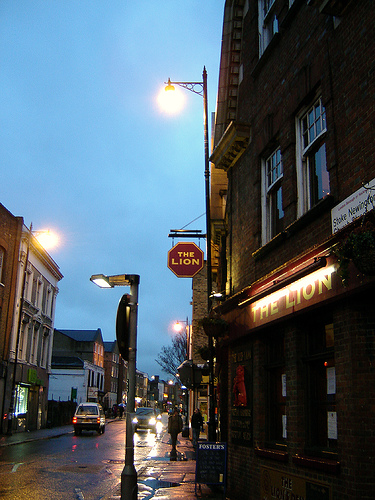<image>Is this a big city? It is ambiguous whether this is a big city or not. Is this a big city? I don't know if this is a big city. It can be either yes or no. 